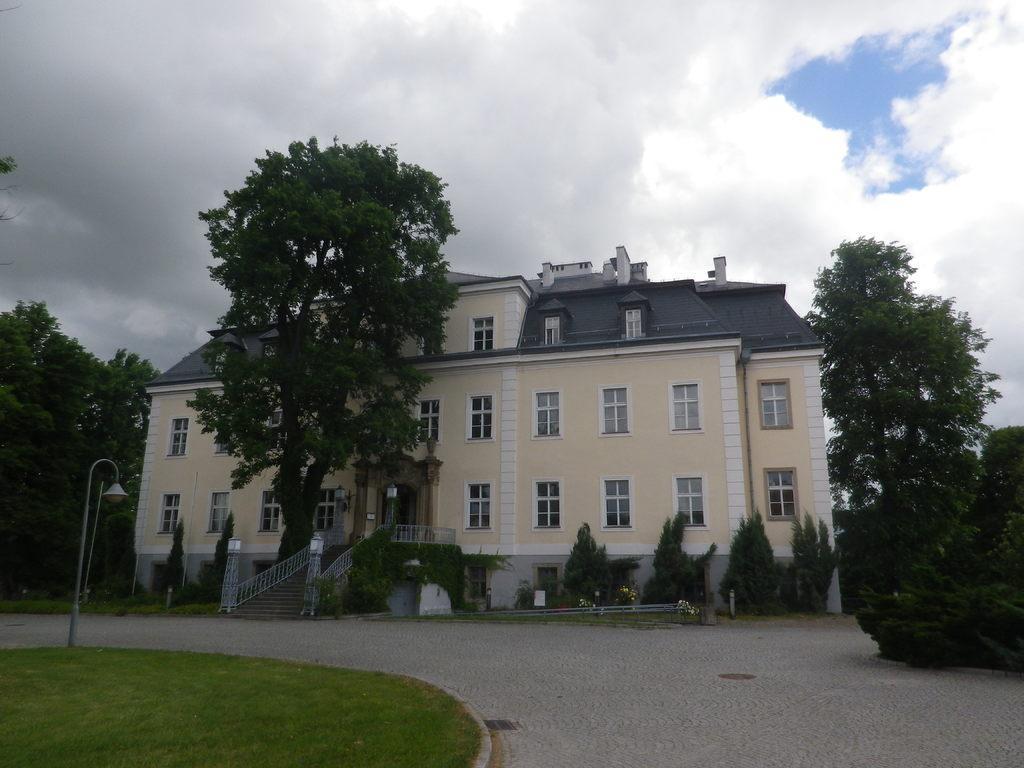How would you summarize this image in a sentence or two? In this image there is a street light on the grassland. There is a building having staircase with few lumps on it. There are few plants on the grassland. There are few trees. Top of image there is sky with some clouds. 